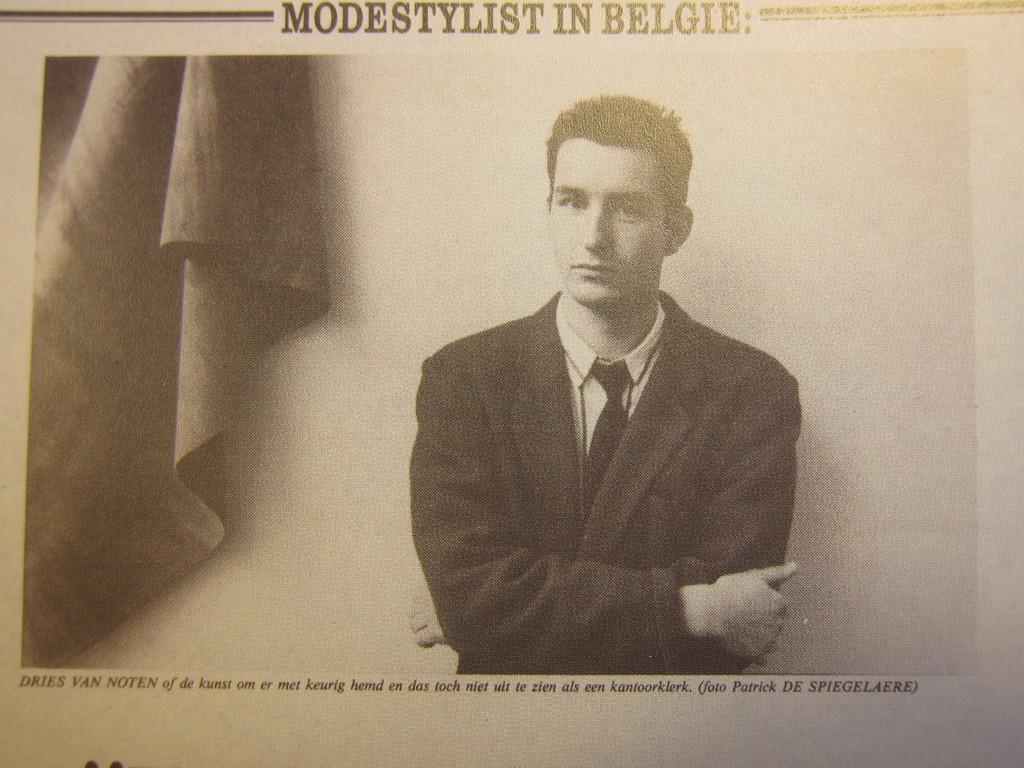In one or two sentences, can you explain what this image depicts? In this image there is a paper in that paper there is one person, cloth and some text. 